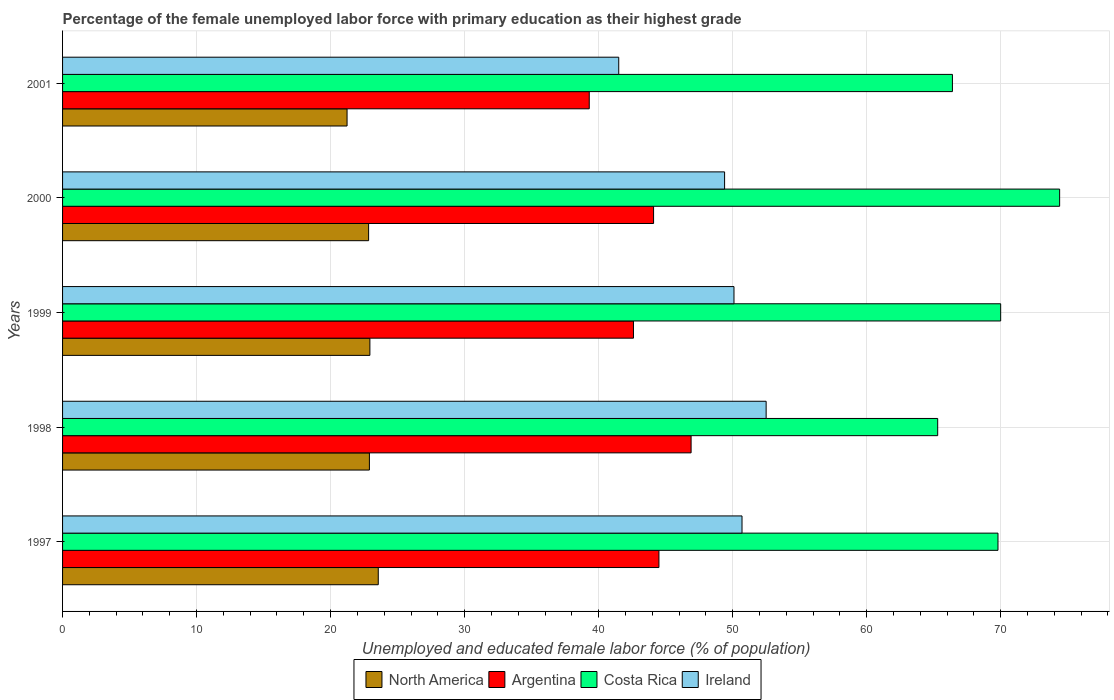Are the number of bars per tick equal to the number of legend labels?
Keep it short and to the point. Yes. How many bars are there on the 5th tick from the bottom?
Make the answer very short. 4. What is the percentage of the unemployed female labor force with primary education in Costa Rica in 1997?
Your answer should be compact. 69.8. Across all years, what is the maximum percentage of the unemployed female labor force with primary education in North America?
Provide a short and direct response. 23.56. Across all years, what is the minimum percentage of the unemployed female labor force with primary education in Ireland?
Keep it short and to the point. 41.5. In which year was the percentage of the unemployed female labor force with primary education in North America maximum?
Offer a terse response. 1997. What is the total percentage of the unemployed female labor force with primary education in North America in the graph?
Your answer should be compact. 113.45. What is the difference between the percentage of the unemployed female labor force with primary education in Argentina in 1997 and that in 2001?
Give a very brief answer. 5.2. What is the difference between the percentage of the unemployed female labor force with primary education in North America in 1999 and the percentage of the unemployed female labor force with primary education in Argentina in 2001?
Provide a succinct answer. -16.37. What is the average percentage of the unemployed female labor force with primary education in North America per year?
Your response must be concise. 22.69. In the year 1997, what is the difference between the percentage of the unemployed female labor force with primary education in Argentina and percentage of the unemployed female labor force with primary education in North America?
Provide a short and direct response. 20.94. What is the ratio of the percentage of the unemployed female labor force with primary education in Argentina in 1999 to that in 2000?
Keep it short and to the point. 0.97. Is the percentage of the unemployed female labor force with primary education in Ireland in 1997 less than that in 2001?
Your response must be concise. No. Is the difference between the percentage of the unemployed female labor force with primary education in Argentina in 1998 and 2000 greater than the difference between the percentage of the unemployed female labor force with primary education in North America in 1998 and 2000?
Offer a very short reply. Yes. What is the difference between the highest and the second highest percentage of the unemployed female labor force with primary education in Argentina?
Your answer should be compact. 2.4. Is the sum of the percentage of the unemployed female labor force with primary education in North America in 1998 and 2001 greater than the maximum percentage of the unemployed female labor force with primary education in Costa Rica across all years?
Provide a short and direct response. No. Is it the case that in every year, the sum of the percentage of the unemployed female labor force with primary education in Costa Rica and percentage of the unemployed female labor force with primary education in Ireland is greater than the sum of percentage of the unemployed female labor force with primary education in Argentina and percentage of the unemployed female labor force with primary education in North America?
Ensure brevity in your answer.  Yes. What does the 3rd bar from the top in 2000 represents?
Your answer should be compact. Argentina. How many bars are there?
Offer a very short reply. 20. Are all the bars in the graph horizontal?
Your answer should be very brief. Yes. What is the difference between two consecutive major ticks on the X-axis?
Keep it short and to the point. 10. Where does the legend appear in the graph?
Provide a short and direct response. Bottom center. How are the legend labels stacked?
Your answer should be very brief. Horizontal. What is the title of the graph?
Give a very brief answer. Percentage of the female unemployed labor force with primary education as their highest grade. What is the label or title of the X-axis?
Your response must be concise. Unemployed and educated female labor force (% of population). What is the Unemployed and educated female labor force (% of population) of North America in 1997?
Your answer should be compact. 23.56. What is the Unemployed and educated female labor force (% of population) of Argentina in 1997?
Keep it short and to the point. 44.5. What is the Unemployed and educated female labor force (% of population) in Costa Rica in 1997?
Your answer should be very brief. 69.8. What is the Unemployed and educated female labor force (% of population) of Ireland in 1997?
Make the answer very short. 50.7. What is the Unemployed and educated female labor force (% of population) in North America in 1998?
Your response must be concise. 22.9. What is the Unemployed and educated female labor force (% of population) of Argentina in 1998?
Keep it short and to the point. 46.9. What is the Unemployed and educated female labor force (% of population) of Costa Rica in 1998?
Your answer should be very brief. 65.3. What is the Unemployed and educated female labor force (% of population) of Ireland in 1998?
Offer a very short reply. 52.5. What is the Unemployed and educated female labor force (% of population) of North America in 1999?
Your response must be concise. 22.93. What is the Unemployed and educated female labor force (% of population) in Argentina in 1999?
Offer a terse response. 42.6. What is the Unemployed and educated female labor force (% of population) in Costa Rica in 1999?
Provide a succinct answer. 70. What is the Unemployed and educated female labor force (% of population) in Ireland in 1999?
Offer a terse response. 50.1. What is the Unemployed and educated female labor force (% of population) of North America in 2000?
Your answer should be compact. 22.84. What is the Unemployed and educated female labor force (% of population) in Argentina in 2000?
Make the answer very short. 44.1. What is the Unemployed and educated female labor force (% of population) in Costa Rica in 2000?
Your response must be concise. 74.4. What is the Unemployed and educated female labor force (% of population) in Ireland in 2000?
Your answer should be very brief. 49.4. What is the Unemployed and educated female labor force (% of population) in North America in 2001?
Make the answer very short. 21.23. What is the Unemployed and educated female labor force (% of population) of Argentina in 2001?
Keep it short and to the point. 39.3. What is the Unemployed and educated female labor force (% of population) of Costa Rica in 2001?
Provide a succinct answer. 66.4. What is the Unemployed and educated female labor force (% of population) of Ireland in 2001?
Your response must be concise. 41.5. Across all years, what is the maximum Unemployed and educated female labor force (% of population) in North America?
Your answer should be very brief. 23.56. Across all years, what is the maximum Unemployed and educated female labor force (% of population) in Argentina?
Provide a short and direct response. 46.9. Across all years, what is the maximum Unemployed and educated female labor force (% of population) of Costa Rica?
Your answer should be very brief. 74.4. Across all years, what is the maximum Unemployed and educated female labor force (% of population) of Ireland?
Keep it short and to the point. 52.5. Across all years, what is the minimum Unemployed and educated female labor force (% of population) in North America?
Provide a short and direct response. 21.23. Across all years, what is the minimum Unemployed and educated female labor force (% of population) in Argentina?
Offer a very short reply. 39.3. Across all years, what is the minimum Unemployed and educated female labor force (% of population) in Costa Rica?
Your answer should be compact. 65.3. Across all years, what is the minimum Unemployed and educated female labor force (% of population) in Ireland?
Your answer should be compact. 41.5. What is the total Unemployed and educated female labor force (% of population) in North America in the graph?
Keep it short and to the point. 113.45. What is the total Unemployed and educated female labor force (% of population) of Argentina in the graph?
Offer a terse response. 217.4. What is the total Unemployed and educated female labor force (% of population) of Costa Rica in the graph?
Make the answer very short. 345.9. What is the total Unemployed and educated female labor force (% of population) of Ireland in the graph?
Your answer should be very brief. 244.2. What is the difference between the Unemployed and educated female labor force (% of population) of North America in 1997 and that in 1998?
Keep it short and to the point. 0.66. What is the difference between the Unemployed and educated female labor force (% of population) of Argentina in 1997 and that in 1998?
Your answer should be very brief. -2.4. What is the difference between the Unemployed and educated female labor force (% of population) of Costa Rica in 1997 and that in 1998?
Your answer should be compact. 4.5. What is the difference between the Unemployed and educated female labor force (% of population) in North America in 1997 and that in 1999?
Offer a terse response. 0.62. What is the difference between the Unemployed and educated female labor force (% of population) of Costa Rica in 1997 and that in 1999?
Offer a very short reply. -0.2. What is the difference between the Unemployed and educated female labor force (% of population) of North America in 1997 and that in 2000?
Your answer should be compact. 0.72. What is the difference between the Unemployed and educated female labor force (% of population) in Argentina in 1997 and that in 2000?
Keep it short and to the point. 0.4. What is the difference between the Unemployed and educated female labor force (% of population) of Costa Rica in 1997 and that in 2000?
Your answer should be very brief. -4.6. What is the difference between the Unemployed and educated female labor force (% of population) of Ireland in 1997 and that in 2000?
Give a very brief answer. 1.3. What is the difference between the Unemployed and educated female labor force (% of population) of North America in 1997 and that in 2001?
Give a very brief answer. 2.33. What is the difference between the Unemployed and educated female labor force (% of population) in Costa Rica in 1997 and that in 2001?
Give a very brief answer. 3.4. What is the difference between the Unemployed and educated female labor force (% of population) of Ireland in 1997 and that in 2001?
Your answer should be compact. 9.2. What is the difference between the Unemployed and educated female labor force (% of population) in North America in 1998 and that in 1999?
Offer a very short reply. -0.04. What is the difference between the Unemployed and educated female labor force (% of population) of Argentina in 1998 and that in 1999?
Ensure brevity in your answer.  4.3. What is the difference between the Unemployed and educated female labor force (% of population) of North America in 1998 and that in 2000?
Your answer should be compact. 0.06. What is the difference between the Unemployed and educated female labor force (% of population) in Costa Rica in 1998 and that in 2000?
Provide a short and direct response. -9.1. What is the difference between the Unemployed and educated female labor force (% of population) in North America in 1998 and that in 2001?
Offer a terse response. 1.67. What is the difference between the Unemployed and educated female labor force (% of population) in Argentina in 1998 and that in 2001?
Offer a terse response. 7.6. What is the difference between the Unemployed and educated female labor force (% of population) of North America in 1999 and that in 2000?
Offer a terse response. 0.1. What is the difference between the Unemployed and educated female labor force (% of population) in Argentina in 1999 and that in 2000?
Provide a succinct answer. -1.5. What is the difference between the Unemployed and educated female labor force (% of population) of North America in 1999 and that in 2001?
Ensure brevity in your answer.  1.7. What is the difference between the Unemployed and educated female labor force (% of population) in Argentina in 1999 and that in 2001?
Provide a short and direct response. 3.3. What is the difference between the Unemployed and educated female labor force (% of population) in Ireland in 1999 and that in 2001?
Your answer should be very brief. 8.6. What is the difference between the Unemployed and educated female labor force (% of population) in North America in 2000 and that in 2001?
Give a very brief answer. 1.61. What is the difference between the Unemployed and educated female labor force (% of population) in Costa Rica in 2000 and that in 2001?
Your answer should be compact. 8. What is the difference between the Unemployed and educated female labor force (% of population) in North America in 1997 and the Unemployed and educated female labor force (% of population) in Argentina in 1998?
Provide a succinct answer. -23.34. What is the difference between the Unemployed and educated female labor force (% of population) of North America in 1997 and the Unemployed and educated female labor force (% of population) of Costa Rica in 1998?
Your answer should be compact. -41.74. What is the difference between the Unemployed and educated female labor force (% of population) of North America in 1997 and the Unemployed and educated female labor force (% of population) of Ireland in 1998?
Give a very brief answer. -28.94. What is the difference between the Unemployed and educated female labor force (% of population) of Argentina in 1997 and the Unemployed and educated female labor force (% of population) of Costa Rica in 1998?
Ensure brevity in your answer.  -20.8. What is the difference between the Unemployed and educated female labor force (% of population) in Argentina in 1997 and the Unemployed and educated female labor force (% of population) in Ireland in 1998?
Provide a short and direct response. -8. What is the difference between the Unemployed and educated female labor force (% of population) of Costa Rica in 1997 and the Unemployed and educated female labor force (% of population) of Ireland in 1998?
Offer a very short reply. 17.3. What is the difference between the Unemployed and educated female labor force (% of population) in North America in 1997 and the Unemployed and educated female labor force (% of population) in Argentina in 1999?
Your answer should be compact. -19.04. What is the difference between the Unemployed and educated female labor force (% of population) of North America in 1997 and the Unemployed and educated female labor force (% of population) of Costa Rica in 1999?
Ensure brevity in your answer.  -46.44. What is the difference between the Unemployed and educated female labor force (% of population) in North America in 1997 and the Unemployed and educated female labor force (% of population) in Ireland in 1999?
Ensure brevity in your answer.  -26.54. What is the difference between the Unemployed and educated female labor force (% of population) in Argentina in 1997 and the Unemployed and educated female labor force (% of population) in Costa Rica in 1999?
Ensure brevity in your answer.  -25.5. What is the difference between the Unemployed and educated female labor force (% of population) in Costa Rica in 1997 and the Unemployed and educated female labor force (% of population) in Ireland in 1999?
Your response must be concise. 19.7. What is the difference between the Unemployed and educated female labor force (% of population) in North America in 1997 and the Unemployed and educated female labor force (% of population) in Argentina in 2000?
Offer a very short reply. -20.54. What is the difference between the Unemployed and educated female labor force (% of population) of North America in 1997 and the Unemployed and educated female labor force (% of population) of Costa Rica in 2000?
Your answer should be very brief. -50.84. What is the difference between the Unemployed and educated female labor force (% of population) of North America in 1997 and the Unemployed and educated female labor force (% of population) of Ireland in 2000?
Make the answer very short. -25.84. What is the difference between the Unemployed and educated female labor force (% of population) in Argentina in 1997 and the Unemployed and educated female labor force (% of population) in Costa Rica in 2000?
Your answer should be compact. -29.9. What is the difference between the Unemployed and educated female labor force (% of population) of Costa Rica in 1997 and the Unemployed and educated female labor force (% of population) of Ireland in 2000?
Make the answer very short. 20.4. What is the difference between the Unemployed and educated female labor force (% of population) in North America in 1997 and the Unemployed and educated female labor force (% of population) in Argentina in 2001?
Provide a short and direct response. -15.74. What is the difference between the Unemployed and educated female labor force (% of population) of North America in 1997 and the Unemployed and educated female labor force (% of population) of Costa Rica in 2001?
Give a very brief answer. -42.84. What is the difference between the Unemployed and educated female labor force (% of population) in North America in 1997 and the Unemployed and educated female labor force (% of population) in Ireland in 2001?
Your answer should be very brief. -17.94. What is the difference between the Unemployed and educated female labor force (% of population) in Argentina in 1997 and the Unemployed and educated female labor force (% of population) in Costa Rica in 2001?
Keep it short and to the point. -21.9. What is the difference between the Unemployed and educated female labor force (% of population) of Costa Rica in 1997 and the Unemployed and educated female labor force (% of population) of Ireland in 2001?
Offer a terse response. 28.3. What is the difference between the Unemployed and educated female labor force (% of population) in North America in 1998 and the Unemployed and educated female labor force (% of population) in Argentina in 1999?
Keep it short and to the point. -19.7. What is the difference between the Unemployed and educated female labor force (% of population) in North America in 1998 and the Unemployed and educated female labor force (% of population) in Costa Rica in 1999?
Ensure brevity in your answer.  -47.1. What is the difference between the Unemployed and educated female labor force (% of population) of North America in 1998 and the Unemployed and educated female labor force (% of population) of Ireland in 1999?
Provide a succinct answer. -27.2. What is the difference between the Unemployed and educated female labor force (% of population) of Argentina in 1998 and the Unemployed and educated female labor force (% of population) of Costa Rica in 1999?
Your answer should be very brief. -23.1. What is the difference between the Unemployed and educated female labor force (% of population) of Costa Rica in 1998 and the Unemployed and educated female labor force (% of population) of Ireland in 1999?
Provide a short and direct response. 15.2. What is the difference between the Unemployed and educated female labor force (% of population) in North America in 1998 and the Unemployed and educated female labor force (% of population) in Argentina in 2000?
Provide a short and direct response. -21.2. What is the difference between the Unemployed and educated female labor force (% of population) of North America in 1998 and the Unemployed and educated female labor force (% of population) of Costa Rica in 2000?
Make the answer very short. -51.5. What is the difference between the Unemployed and educated female labor force (% of population) of North America in 1998 and the Unemployed and educated female labor force (% of population) of Ireland in 2000?
Provide a short and direct response. -26.5. What is the difference between the Unemployed and educated female labor force (% of population) of Argentina in 1998 and the Unemployed and educated female labor force (% of population) of Costa Rica in 2000?
Keep it short and to the point. -27.5. What is the difference between the Unemployed and educated female labor force (% of population) of Argentina in 1998 and the Unemployed and educated female labor force (% of population) of Ireland in 2000?
Offer a terse response. -2.5. What is the difference between the Unemployed and educated female labor force (% of population) in Costa Rica in 1998 and the Unemployed and educated female labor force (% of population) in Ireland in 2000?
Provide a succinct answer. 15.9. What is the difference between the Unemployed and educated female labor force (% of population) in North America in 1998 and the Unemployed and educated female labor force (% of population) in Argentina in 2001?
Offer a very short reply. -16.4. What is the difference between the Unemployed and educated female labor force (% of population) of North America in 1998 and the Unemployed and educated female labor force (% of population) of Costa Rica in 2001?
Your answer should be very brief. -43.5. What is the difference between the Unemployed and educated female labor force (% of population) in North America in 1998 and the Unemployed and educated female labor force (% of population) in Ireland in 2001?
Your answer should be very brief. -18.6. What is the difference between the Unemployed and educated female labor force (% of population) of Argentina in 1998 and the Unemployed and educated female labor force (% of population) of Costa Rica in 2001?
Provide a short and direct response. -19.5. What is the difference between the Unemployed and educated female labor force (% of population) in Costa Rica in 1998 and the Unemployed and educated female labor force (% of population) in Ireland in 2001?
Give a very brief answer. 23.8. What is the difference between the Unemployed and educated female labor force (% of population) in North America in 1999 and the Unemployed and educated female labor force (% of population) in Argentina in 2000?
Provide a short and direct response. -21.17. What is the difference between the Unemployed and educated female labor force (% of population) of North America in 1999 and the Unemployed and educated female labor force (% of population) of Costa Rica in 2000?
Your response must be concise. -51.47. What is the difference between the Unemployed and educated female labor force (% of population) of North America in 1999 and the Unemployed and educated female labor force (% of population) of Ireland in 2000?
Keep it short and to the point. -26.47. What is the difference between the Unemployed and educated female labor force (% of population) in Argentina in 1999 and the Unemployed and educated female labor force (% of population) in Costa Rica in 2000?
Your response must be concise. -31.8. What is the difference between the Unemployed and educated female labor force (% of population) in Costa Rica in 1999 and the Unemployed and educated female labor force (% of population) in Ireland in 2000?
Keep it short and to the point. 20.6. What is the difference between the Unemployed and educated female labor force (% of population) in North America in 1999 and the Unemployed and educated female labor force (% of population) in Argentina in 2001?
Offer a very short reply. -16.37. What is the difference between the Unemployed and educated female labor force (% of population) of North America in 1999 and the Unemployed and educated female labor force (% of population) of Costa Rica in 2001?
Make the answer very short. -43.47. What is the difference between the Unemployed and educated female labor force (% of population) in North America in 1999 and the Unemployed and educated female labor force (% of population) in Ireland in 2001?
Make the answer very short. -18.57. What is the difference between the Unemployed and educated female labor force (% of population) of Argentina in 1999 and the Unemployed and educated female labor force (% of population) of Costa Rica in 2001?
Ensure brevity in your answer.  -23.8. What is the difference between the Unemployed and educated female labor force (% of population) of Argentina in 1999 and the Unemployed and educated female labor force (% of population) of Ireland in 2001?
Offer a terse response. 1.1. What is the difference between the Unemployed and educated female labor force (% of population) in North America in 2000 and the Unemployed and educated female labor force (% of population) in Argentina in 2001?
Keep it short and to the point. -16.46. What is the difference between the Unemployed and educated female labor force (% of population) of North America in 2000 and the Unemployed and educated female labor force (% of population) of Costa Rica in 2001?
Your response must be concise. -43.56. What is the difference between the Unemployed and educated female labor force (% of population) in North America in 2000 and the Unemployed and educated female labor force (% of population) in Ireland in 2001?
Your answer should be compact. -18.66. What is the difference between the Unemployed and educated female labor force (% of population) in Argentina in 2000 and the Unemployed and educated female labor force (% of population) in Costa Rica in 2001?
Offer a very short reply. -22.3. What is the difference between the Unemployed and educated female labor force (% of population) in Argentina in 2000 and the Unemployed and educated female labor force (% of population) in Ireland in 2001?
Keep it short and to the point. 2.6. What is the difference between the Unemployed and educated female labor force (% of population) of Costa Rica in 2000 and the Unemployed and educated female labor force (% of population) of Ireland in 2001?
Offer a terse response. 32.9. What is the average Unemployed and educated female labor force (% of population) of North America per year?
Your response must be concise. 22.69. What is the average Unemployed and educated female labor force (% of population) in Argentina per year?
Provide a succinct answer. 43.48. What is the average Unemployed and educated female labor force (% of population) of Costa Rica per year?
Give a very brief answer. 69.18. What is the average Unemployed and educated female labor force (% of population) in Ireland per year?
Offer a very short reply. 48.84. In the year 1997, what is the difference between the Unemployed and educated female labor force (% of population) in North America and Unemployed and educated female labor force (% of population) in Argentina?
Provide a succinct answer. -20.94. In the year 1997, what is the difference between the Unemployed and educated female labor force (% of population) of North America and Unemployed and educated female labor force (% of population) of Costa Rica?
Make the answer very short. -46.24. In the year 1997, what is the difference between the Unemployed and educated female labor force (% of population) of North America and Unemployed and educated female labor force (% of population) of Ireland?
Offer a very short reply. -27.14. In the year 1997, what is the difference between the Unemployed and educated female labor force (% of population) in Argentina and Unemployed and educated female labor force (% of population) in Costa Rica?
Offer a very short reply. -25.3. In the year 1997, what is the difference between the Unemployed and educated female labor force (% of population) in Argentina and Unemployed and educated female labor force (% of population) in Ireland?
Give a very brief answer. -6.2. In the year 1997, what is the difference between the Unemployed and educated female labor force (% of population) in Costa Rica and Unemployed and educated female labor force (% of population) in Ireland?
Your answer should be compact. 19.1. In the year 1998, what is the difference between the Unemployed and educated female labor force (% of population) of North America and Unemployed and educated female labor force (% of population) of Argentina?
Give a very brief answer. -24. In the year 1998, what is the difference between the Unemployed and educated female labor force (% of population) of North America and Unemployed and educated female labor force (% of population) of Costa Rica?
Your answer should be very brief. -42.4. In the year 1998, what is the difference between the Unemployed and educated female labor force (% of population) of North America and Unemployed and educated female labor force (% of population) of Ireland?
Offer a very short reply. -29.6. In the year 1998, what is the difference between the Unemployed and educated female labor force (% of population) in Argentina and Unemployed and educated female labor force (% of population) in Costa Rica?
Your response must be concise. -18.4. In the year 1999, what is the difference between the Unemployed and educated female labor force (% of population) of North America and Unemployed and educated female labor force (% of population) of Argentina?
Provide a succinct answer. -19.67. In the year 1999, what is the difference between the Unemployed and educated female labor force (% of population) in North America and Unemployed and educated female labor force (% of population) in Costa Rica?
Provide a succinct answer. -47.07. In the year 1999, what is the difference between the Unemployed and educated female labor force (% of population) in North America and Unemployed and educated female labor force (% of population) in Ireland?
Ensure brevity in your answer.  -27.17. In the year 1999, what is the difference between the Unemployed and educated female labor force (% of population) of Argentina and Unemployed and educated female labor force (% of population) of Costa Rica?
Provide a succinct answer. -27.4. In the year 2000, what is the difference between the Unemployed and educated female labor force (% of population) of North America and Unemployed and educated female labor force (% of population) of Argentina?
Provide a succinct answer. -21.26. In the year 2000, what is the difference between the Unemployed and educated female labor force (% of population) of North America and Unemployed and educated female labor force (% of population) of Costa Rica?
Offer a very short reply. -51.56. In the year 2000, what is the difference between the Unemployed and educated female labor force (% of population) of North America and Unemployed and educated female labor force (% of population) of Ireland?
Keep it short and to the point. -26.56. In the year 2000, what is the difference between the Unemployed and educated female labor force (% of population) of Argentina and Unemployed and educated female labor force (% of population) of Costa Rica?
Your answer should be very brief. -30.3. In the year 2000, what is the difference between the Unemployed and educated female labor force (% of population) of Argentina and Unemployed and educated female labor force (% of population) of Ireland?
Your answer should be very brief. -5.3. In the year 2001, what is the difference between the Unemployed and educated female labor force (% of population) in North America and Unemployed and educated female labor force (% of population) in Argentina?
Offer a very short reply. -18.07. In the year 2001, what is the difference between the Unemployed and educated female labor force (% of population) in North America and Unemployed and educated female labor force (% of population) in Costa Rica?
Your response must be concise. -45.17. In the year 2001, what is the difference between the Unemployed and educated female labor force (% of population) in North America and Unemployed and educated female labor force (% of population) in Ireland?
Provide a succinct answer. -20.27. In the year 2001, what is the difference between the Unemployed and educated female labor force (% of population) of Argentina and Unemployed and educated female labor force (% of population) of Costa Rica?
Your response must be concise. -27.1. In the year 2001, what is the difference between the Unemployed and educated female labor force (% of population) of Costa Rica and Unemployed and educated female labor force (% of population) of Ireland?
Give a very brief answer. 24.9. What is the ratio of the Unemployed and educated female labor force (% of population) in North America in 1997 to that in 1998?
Your response must be concise. 1.03. What is the ratio of the Unemployed and educated female labor force (% of population) in Argentina in 1997 to that in 1998?
Ensure brevity in your answer.  0.95. What is the ratio of the Unemployed and educated female labor force (% of population) of Costa Rica in 1997 to that in 1998?
Give a very brief answer. 1.07. What is the ratio of the Unemployed and educated female labor force (% of population) in Ireland in 1997 to that in 1998?
Your answer should be very brief. 0.97. What is the ratio of the Unemployed and educated female labor force (% of population) in North America in 1997 to that in 1999?
Ensure brevity in your answer.  1.03. What is the ratio of the Unemployed and educated female labor force (% of population) in Argentina in 1997 to that in 1999?
Your response must be concise. 1.04. What is the ratio of the Unemployed and educated female labor force (% of population) of North America in 1997 to that in 2000?
Ensure brevity in your answer.  1.03. What is the ratio of the Unemployed and educated female labor force (% of population) in Argentina in 1997 to that in 2000?
Ensure brevity in your answer.  1.01. What is the ratio of the Unemployed and educated female labor force (% of population) of Costa Rica in 1997 to that in 2000?
Provide a succinct answer. 0.94. What is the ratio of the Unemployed and educated female labor force (% of population) of Ireland in 1997 to that in 2000?
Give a very brief answer. 1.03. What is the ratio of the Unemployed and educated female labor force (% of population) of North America in 1997 to that in 2001?
Provide a succinct answer. 1.11. What is the ratio of the Unemployed and educated female labor force (% of population) in Argentina in 1997 to that in 2001?
Your response must be concise. 1.13. What is the ratio of the Unemployed and educated female labor force (% of population) of Costa Rica in 1997 to that in 2001?
Your response must be concise. 1.05. What is the ratio of the Unemployed and educated female labor force (% of population) in Ireland in 1997 to that in 2001?
Provide a short and direct response. 1.22. What is the ratio of the Unemployed and educated female labor force (% of population) in Argentina in 1998 to that in 1999?
Provide a succinct answer. 1.1. What is the ratio of the Unemployed and educated female labor force (% of population) in Costa Rica in 1998 to that in 1999?
Offer a very short reply. 0.93. What is the ratio of the Unemployed and educated female labor force (% of population) in Ireland in 1998 to that in 1999?
Provide a short and direct response. 1.05. What is the ratio of the Unemployed and educated female labor force (% of population) in North America in 1998 to that in 2000?
Your response must be concise. 1. What is the ratio of the Unemployed and educated female labor force (% of population) in Argentina in 1998 to that in 2000?
Keep it short and to the point. 1.06. What is the ratio of the Unemployed and educated female labor force (% of population) of Costa Rica in 1998 to that in 2000?
Offer a terse response. 0.88. What is the ratio of the Unemployed and educated female labor force (% of population) of Ireland in 1998 to that in 2000?
Offer a very short reply. 1.06. What is the ratio of the Unemployed and educated female labor force (% of population) in North America in 1998 to that in 2001?
Ensure brevity in your answer.  1.08. What is the ratio of the Unemployed and educated female labor force (% of population) in Argentina in 1998 to that in 2001?
Your answer should be very brief. 1.19. What is the ratio of the Unemployed and educated female labor force (% of population) of Costa Rica in 1998 to that in 2001?
Ensure brevity in your answer.  0.98. What is the ratio of the Unemployed and educated female labor force (% of population) of Ireland in 1998 to that in 2001?
Provide a short and direct response. 1.27. What is the ratio of the Unemployed and educated female labor force (% of population) in North America in 1999 to that in 2000?
Your answer should be compact. 1. What is the ratio of the Unemployed and educated female labor force (% of population) in Costa Rica in 1999 to that in 2000?
Ensure brevity in your answer.  0.94. What is the ratio of the Unemployed and educated female labor force (% of population) of Ireland in 1999 to that in 2000?
Ensure brevity in your answer.  1.01. What is the ratio of the Unemployed and educated female labor force (% of population) in North America in 1999 to that in 2001?
Provide a short and direct response. 1.08. What is the ratio of the Unemployed and educated female labor force (% of population) of Argentina in 1999 to that in 2001?
Make the answer very short. 1.08. What is the ratio of the Unemployed and educated female labor force (% of population) in Costa Rica in 1999 to that in 2001?
Offer a terse response. 1.05. What is the ratio of the Unemployed and educated female labor force (% of population) of Ireland in 1999 to that in 2001?
Your response must be concise. 1.21. What is the ratio of the Unemployed and educated female labor force (% of population) of North America in 2000 to that in 2001?
Offer a terse response. 1.08. What is the ratio of the Unemployed and educated female labor force (% of population) of Argentina in 2000 to that in 2001?
Make the answer very short. 1.12. What is the ratio of the Unemployed and educated female labor force (% of population) of Costa Rica in 2000 to that in 2001?
Your answer should be compact. 1.12. What is the ratio of the Unemployed and educated female labor force (% of population) of Ireland in 2000 to that in 2001?
Your answer should be compact. 1.19. What is the difference between the highest and the second highest Unemployed and educated female labor force (% of population) in North America?
Your answer should be very brief. 0.62. What is the difference between the highest and the second highest Unemployed and educated female labor force (% of population) of Costa Rica?
Your answer should be very brief. 4.4. What is the difference between the highest and the lowest Unemployed and educated female labor force (% of population) of North America?
Keep it short and to the point. 2.33. What is the difference between the highest and the lowest Unemployed and educated female labor force (% of population) of Costa Rica?
Provide a succinct answer. 9.1. 